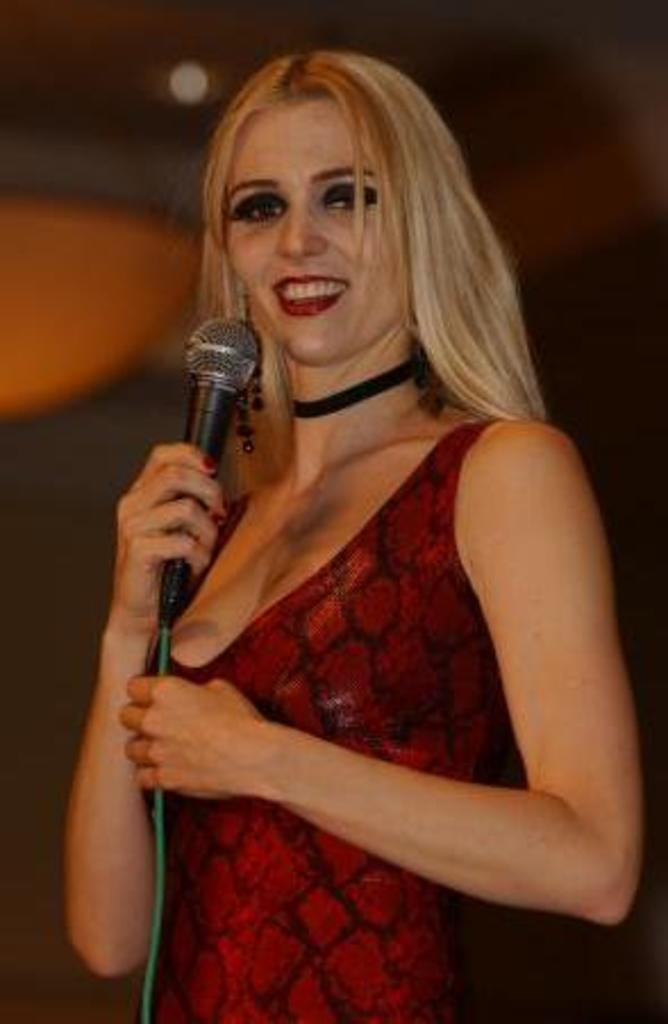Who or what is present in the image? There is a person in the image. What is the person doing in the image? The person is standing in the image. What object is the person holding in the image? The person is holding a microphone in the image. What type of mine can be seen in the background of the image? There is no mine present in the image; it only features a person standing and holding a microphone. 